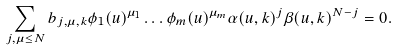Convert formula to latex. <formula><loc_0><loc_0><loc_500><loc_500>\sum _ { j , \mu \leq N } b _ { j , \mu , k } \phi _ { 1 } ( u ) ^ { \mu _ { 1 } } \dots \phi _ { m } ( u ) ^ { \mu _ { m } } \alpha ( u , k ) ^ { j } \beta ( u , k ) ^ { N - j } = 0 .</formula> 